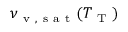<formula> <loc_0><loc_0><loc_500><loc_500>\nu _ { v , s a t } ( T _ { T } )</formula> 